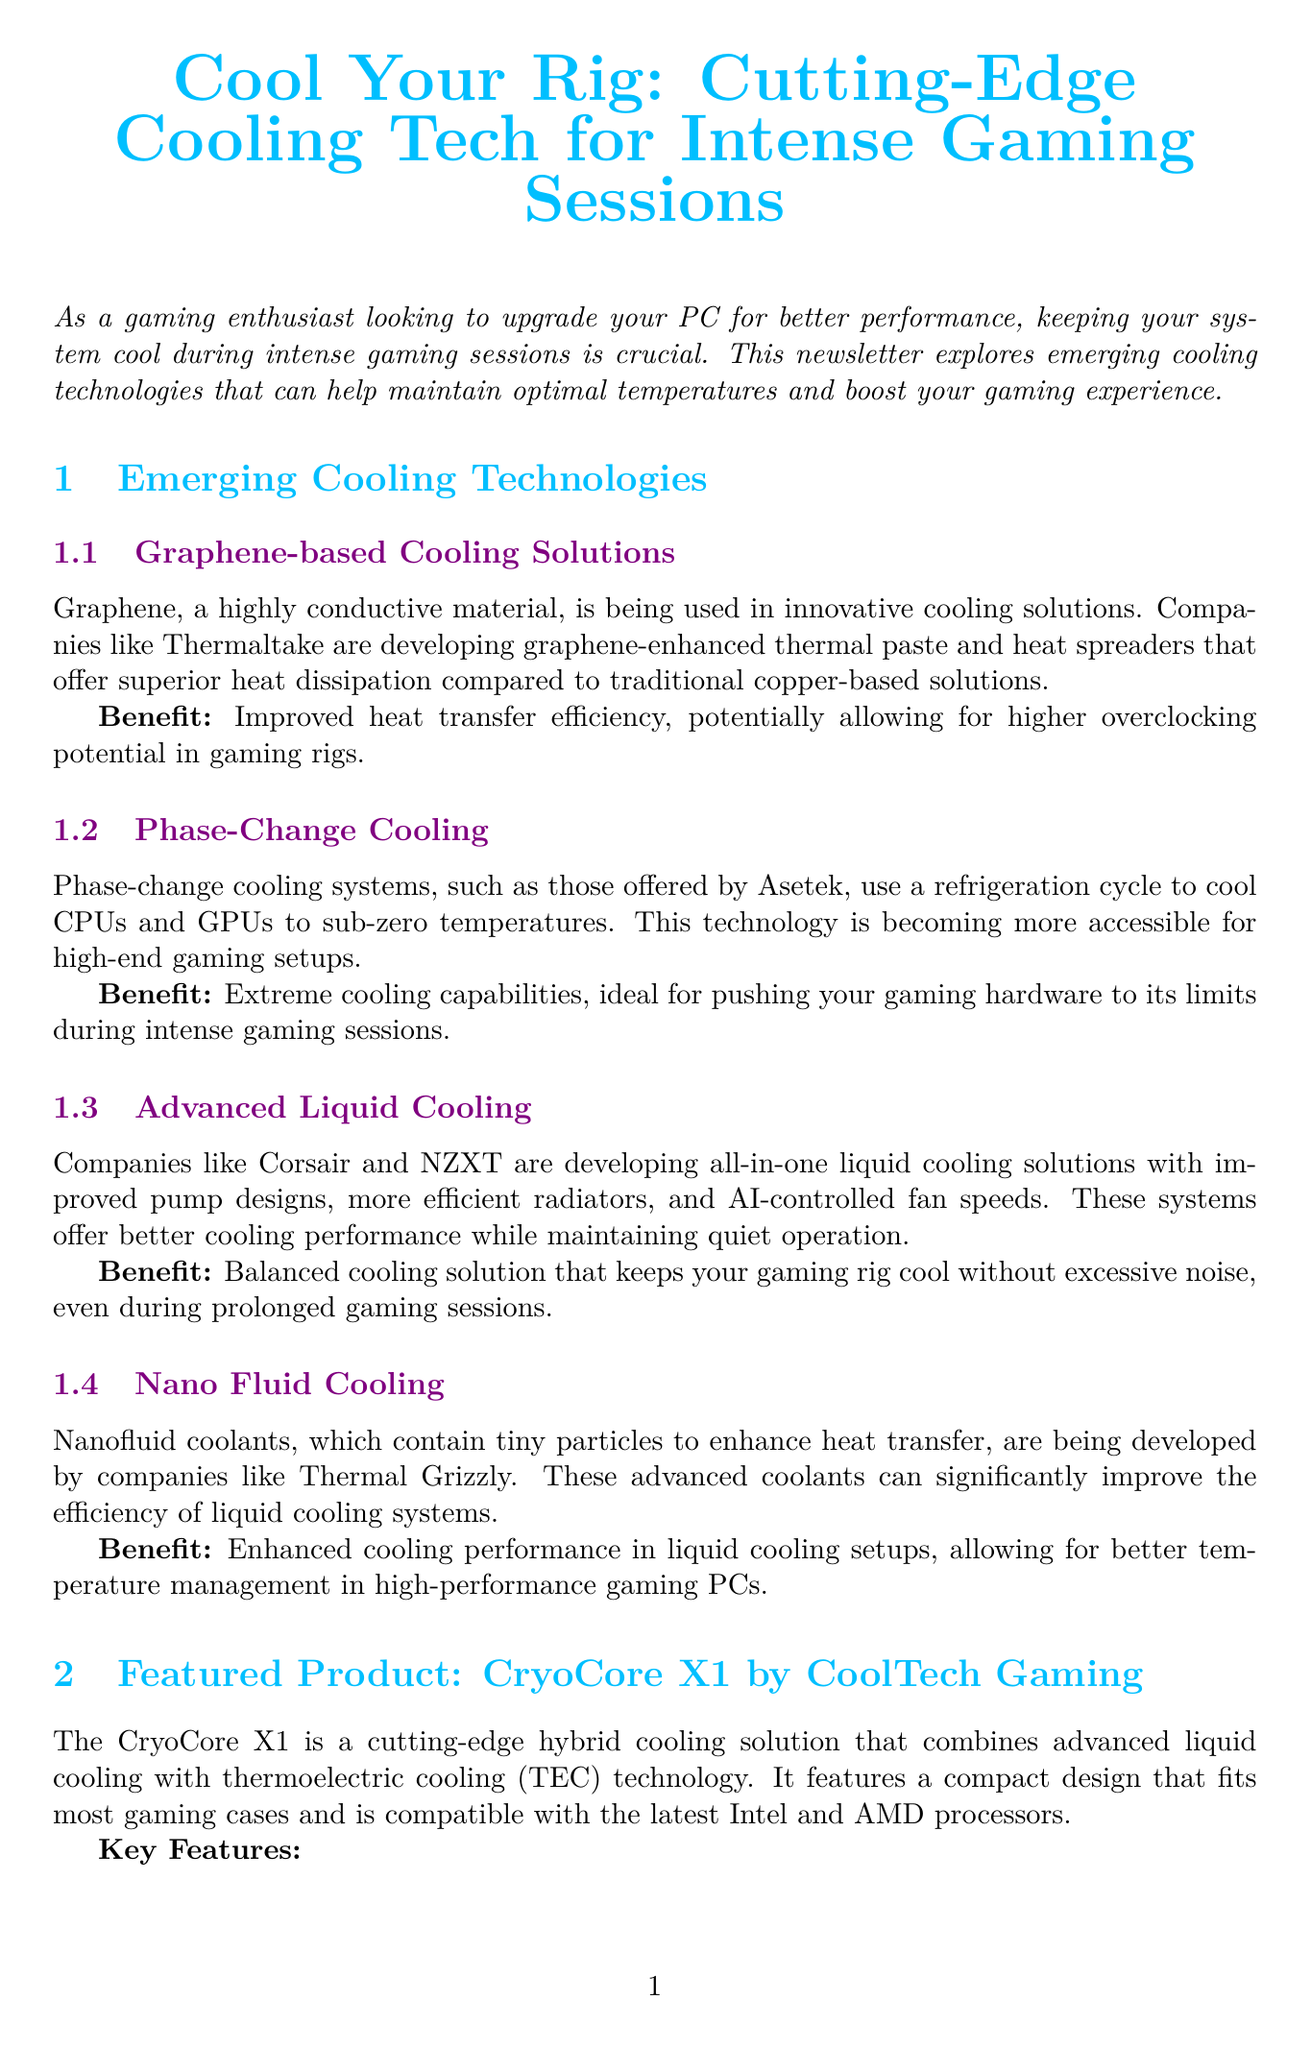What is the title of the newsletter? The title of the newsletter is presented at the top of the document.
Answer: Cool Your Rig: Cutting-Edge Cooling Tech for Intense Gaming Sessions Who is developing graphene-based cooling solutions? The document mentions companies involved in developing graphene-based cooling technologies.
Answer: Thermaltake What is the price of the CryoCore X1? The price of the featured product is clearly stated in the document.
Answer: $299.99 What is a benefit of nanofluid cooling? The document lists specific benefits for each cooling technology mentioned.
Answer: Enhanced cooling performance in liquid cooling setups What technology does the CryoCore X1 combine? The featured product combines two specific cooling technologies as described in the document.
Answer: Advanced liquid cooling and thermoelectric cooling (TEC) technology What should you regularly clean to maintain cooling performance? The tips section recommends maintenance for specific components in the cooling system.
Answer: Cooling components Which companies are known for advanced liquid cooling solutions? The document names companies that are developing liquid cooling products.
Answer: Corsair and NZXT What temperature range does phase-change cooling achieve? The description states what temperatures phase-change cooling can reach and its purpose.
Answer: Sub-zero temperatures 